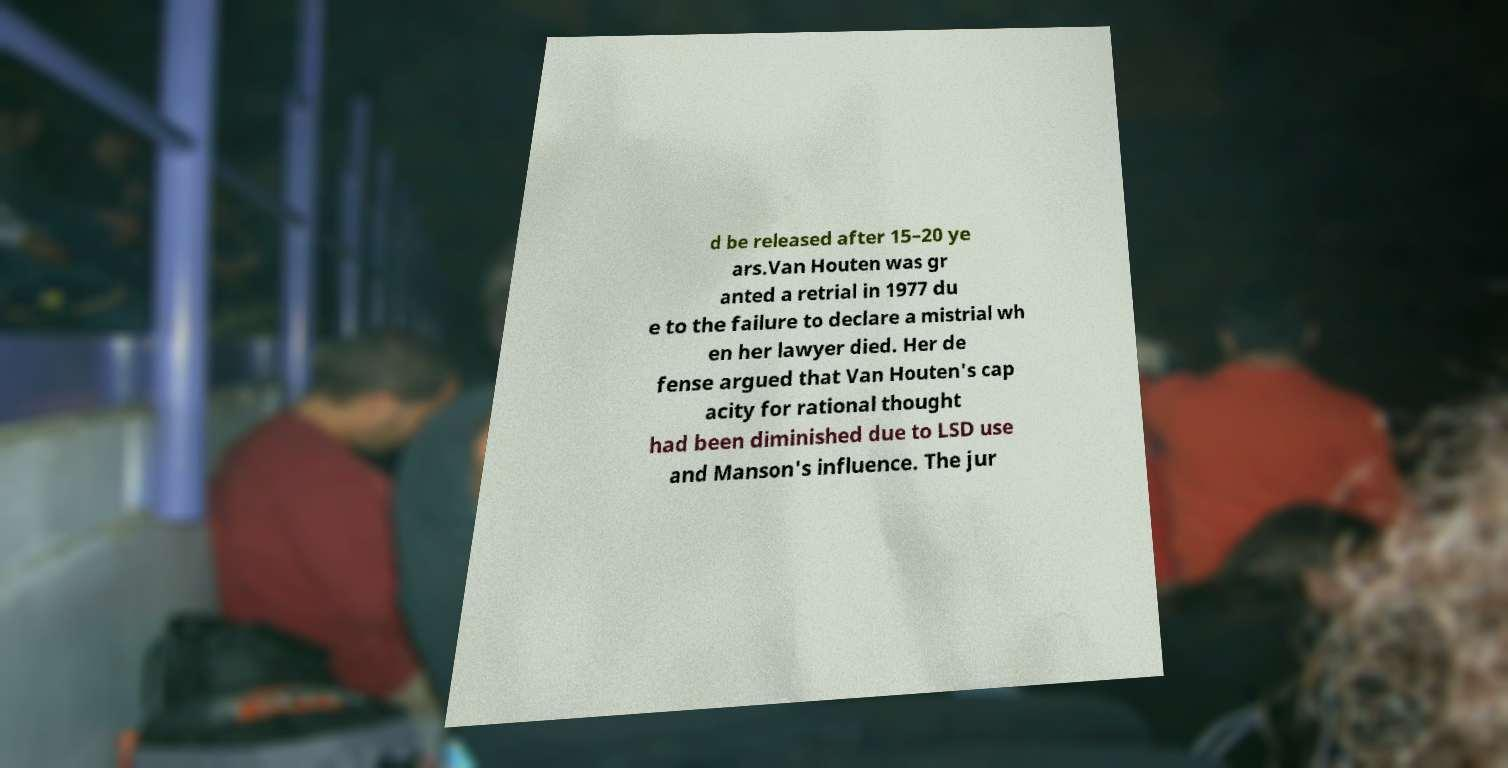Please identify and transcribe the text found in this image. d be released after 15–20 ye ars.Van Houten was gr anted a retrial in 1977 du e to the failure to declare a mistrial wh en her lawyer died. Her de fense argued that Van Houten's cap acity for rational thought had been diminished due to LSD use and Manson's influence. The jur 